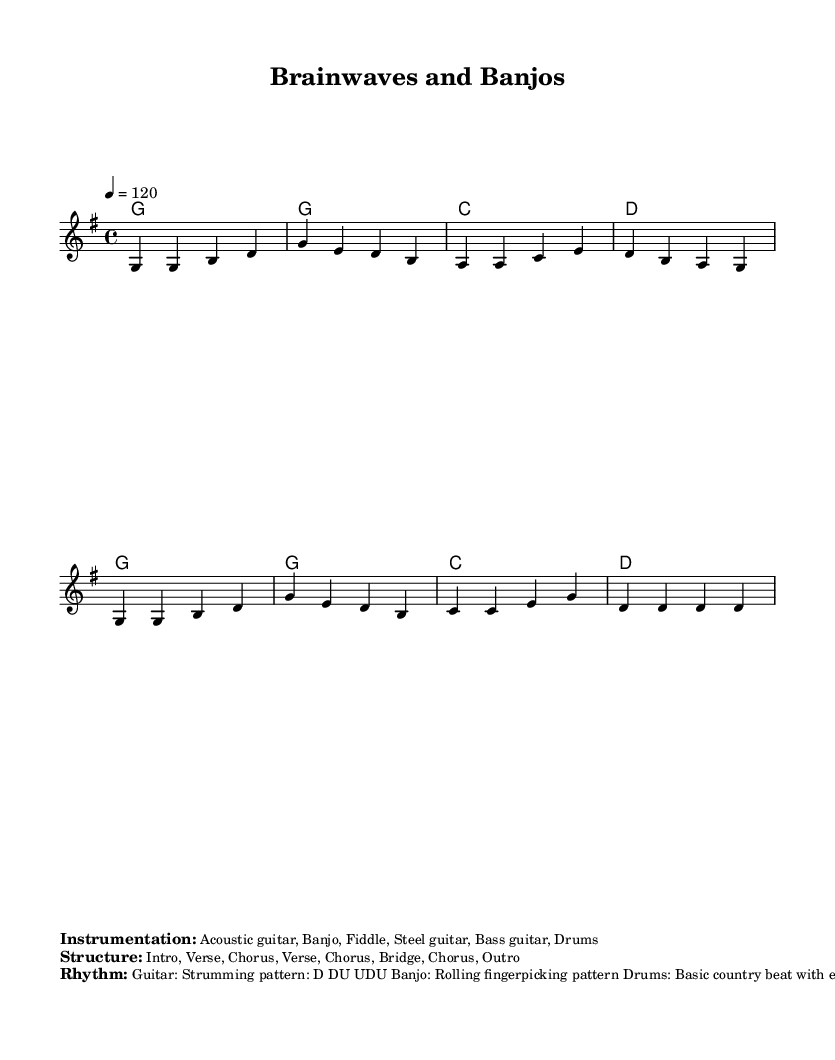What is the key signature of this music? The key signature is G major, which has one sharp (F#). This is indicated at the beginning of the sheet music.
Answer: G major What is the time signature of the piece? The time signature shown at the beginning is 4/4, which means there are four beats in each measure. This is indicated next to the clef sign in the sheet music.
Answer: 4/4 What is the tempo of the piece? The tempo marking is shown as 4 = 120, indicating that the quarter note is played at 120 beats per minute. This is visible in the header of the sheet music.
Answer: 120 What is the strumming pattern for the guitar? The strumming pattern for the guitar is specified as D DU UDU, which outlines the rhythm for strumming each chord in the piece. This detail is included in the markup section.
Answer: D DU UDU What instruments are used in this piece? The instrumentation includes acoustic guitar, banjo, fiddle, steel guitar, bass guitar, and drums. This information is presented in the markup section of the score.
Answer: Acoustic guitar, banjo, fiddle, steel guitar, bass guitar, drums How many sections does the structure have? The structure of this piece includes eight sections: Intro, Verse, Chorus, Verse, Chorus, Bridge, Chorus, and Outro. This is detailed in the markup section that outlines the structure.
Answer: Eight sections What is the primary feel of the rhythms used? The primary rhythm type is characterized by a basic country beat, especially emphasizing the 2 and 4 beats of each measure. This rhythmic style is common in the instructions provided for the drums in the markup.
Answer: Basic country beat 